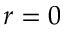Convert formula to latex. <formula><loc_0><loc_0><loc_500><loc_500>r = 0</formula> 